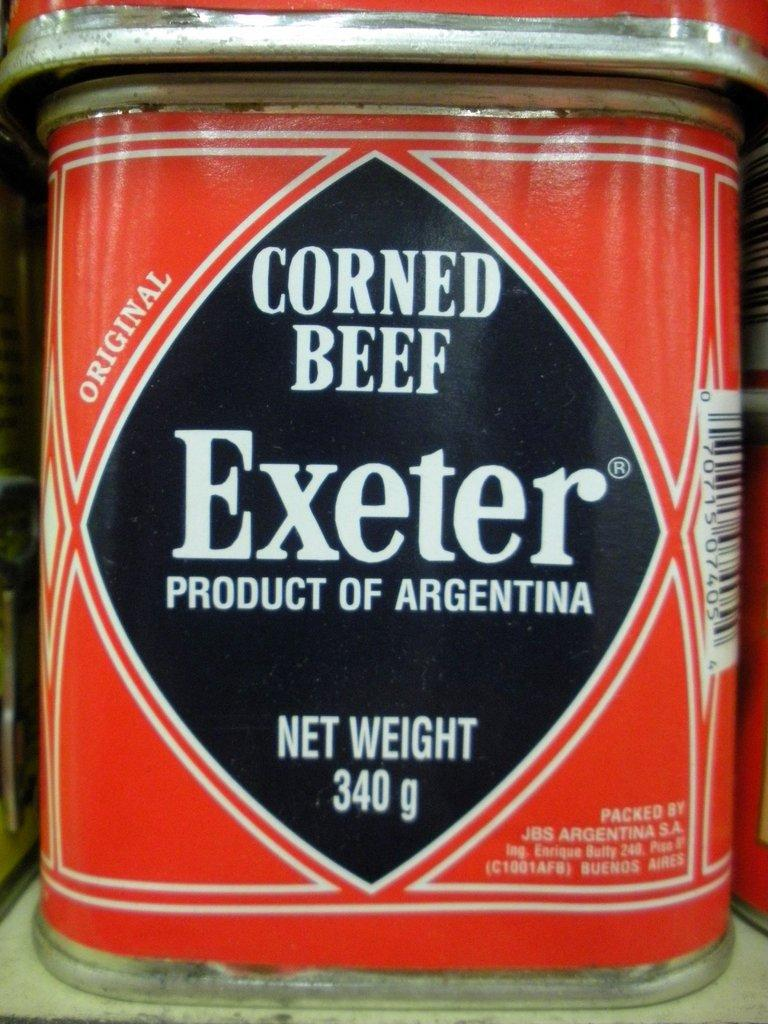<image>
Write a terse but informative summary of the picture. A 340 gram can of corned beef sits on the shelf. 